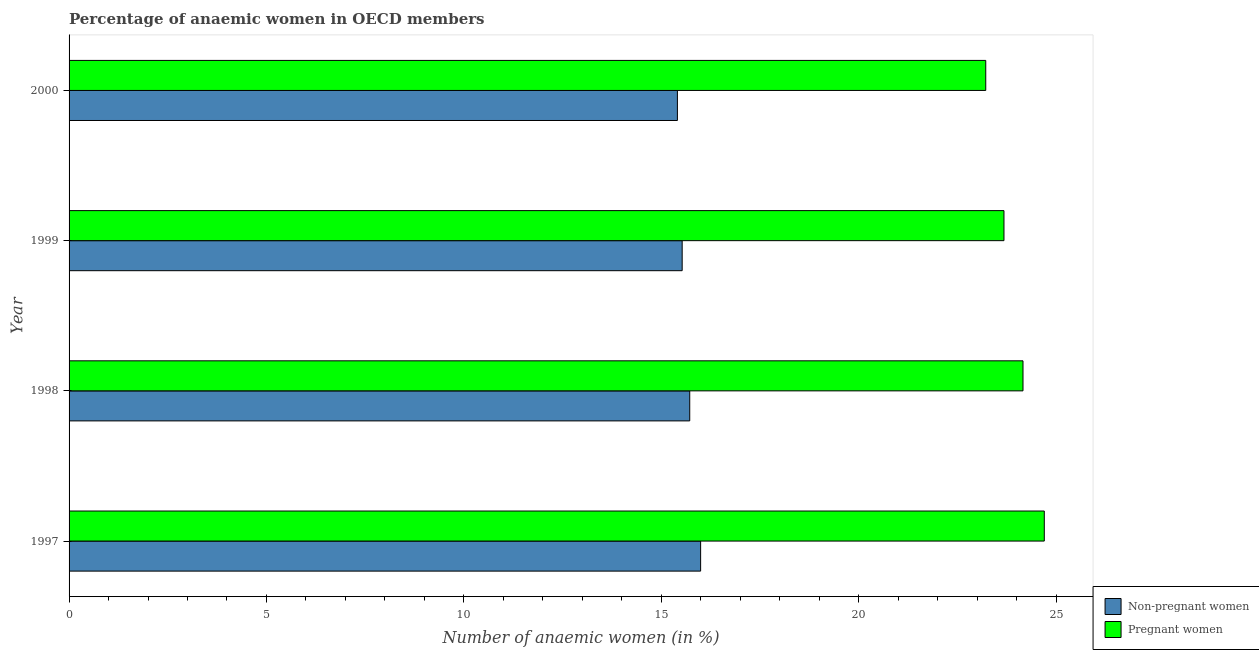Are the number of bars per tick equal to the number of legend labels?
Provide a short and direct response. Yes. How many bars are there on the 3rd tick from the top?
Offer a very short reply. 2. How many bars are there on the 2nd tick from the bottom?
Ensure brevity in your answer.  2. In how many cases, is the number of bars for a given year not equal to the number of legend labels?
Keep it short and to the point. 0. What is the percentage of pregnant anaemic women in 1997?
Provide a short and direct response. 24.7. Across all years, what is the maximum percentage of pregnant anaemic women?
Give a very brief answer. 24.7. Across all years, what is the minimum percentage of pregnant anaemic women?
Ensure brevity in your answer.  23.22. In which year was the percentage of non-pregnant anaemic women minimum?
Your response must be concise. 2000. What is the total percentage of pregnant anaemic women in the graph?
Your answer should be very brief. 95.77. What is the difference between the percentage of pregnant anaemic women in 1998 and that in 1999?
Give a very brief answer. 0.48. What is the difference between the percentage of pregnant anaemic women in 1998 and the percentage of non-pregnant anaemic women in 2000?
Provide a short and direct response. 8.75. What is the average percentage of non-pregnant anaemic women per year?
Provide a short and direct response. 15.66. In the year 1997, what is the difference between the percentage of pregnant anaemic women and percentage of non-pregnant anaemic women?
Provide a short and direct response. 8.71. In how many years, is the percentage of pregnant anaemic women greater than 15 %?
Your answer should be compact. 4. What is the ratio of the percentage of non-pregnant anaemic women in 1998 to that in 2000?
Make the answer very short. 1.02. What is the difference between the highest and the second highest percentage of pregnant anaemic women?
Keep it short and to the point. 0.54. What is the difference between the highest and the lowest percentage of pregnant anaemic women?
Your answer should be very brief. 1.48. In how many years, is the percentage of pregnant anaemic women greater than the average percentage of pregnant anaemic women taken over all years?
Provide a succinct answer. 2. What does the 2nd bar from the top in 2000 represents?
Your answer should be compact. Non-pregnant women. What does the 1st bar from the bottom in 1998 represents?
Give a very brief answer. Non-pregnant women. How many bars are there?
Ensure brevity in your answer.  8. Are all the bars in the graph horizontal?
Provide a short and direct response. Yes. What is the difference between two consecutive major ticks on the X-axis?
Your answer should be very brief. 5. Does the graph contain grids?
Keep it short and to the point. No. How are the legend labels stacked?
Your response must be concise. Vertical. What is the title of the graph?
Keep it short and to the point. Percentage of anaemic women in OECD members. What is the label or title of the X-axis?
Give a very brief answer. Number of anaemic women (in %). What is the label or title of the Y-axis?
Your response must be concise. Year. What is the Number of anaemic women (in %) in Non-pregnant women in 1997?
Provide a succinct answer. 16. What is the Number of anaemic women (in %) of Pregnant women in 1997?
Your answer should be compact. 24.7. What is the Number of anaemic women (in %) of Non-pregnant women in 1998?
Offer a very short reply. 15.72. What is the Number of anaemic women (in %) of Pregnant women in 1998?
Your answer should be very brief. 24.16. What is the Number of anaemic women (in %) of Non-pregnant women in 1999?
Provide a succinct answer. 15.53. What is the Number of anaemic women (in %) in Pregnant women in 1999?
Your response must be concise. 23.68. What is the Number of anaemic women (in %) of Non-pregnant women in 2000?
Keep it short and to the point. 15.41. What is the Number of anaemic women (in %) of Pregnant women in 2000?
Your response must be concise. 23.22. Across all years, what is the maximum Number of anaemic women (in %) of Non-pregnant women?
Offer a terse response. 16. Across all years, what is the maximum Number of anaemic women (in %) in Pregnant women?
Provide a short and direct response. 24.7. Across all years, what is the minimum Number of anaemic women (in %) of Non-pregnant women?
Provide a short and direct response. 15.41. Across all years, what is the minimum Number of anaemic women (in %) in Pregnant women?
Give a very brief answer. 23.22. What is the total Number of anaemic women (in %) in Non-pregnant women in the graph?
Provide a succinct answer. 62.66. What is the total Number of anaemic women (in %) of Pregnant women in the graph?
Make the answer very short. 95.77. What is the difference between the Number of anaemic women (in %) in Non-pregnant women in 1997 and that in 1998?
Your response must be concise. 0.28. What is the difference between the Number of anaemic women (in %) of Pregnant women in 1997 and that in 1998?
Your response must be concise. 0.54. What is the difference between the Number of anaemic women (in %) in Non-pregnant women in 1997 and that in 1999?
Your answer should be compact. 0.47. What is the difference between the Number of anaemic women (in %) of Pregnant women in 1997 and that in 1999?
Ensure brevity in your answer.  1.02. What is the difference between the Number of anaemic women (in %) in Non-pregnant women in 1997 and that in 2000?
Offer a terse response. 0.59. What is the difference between the Number of anaemic women (in %) of Pregnant women in 1997 and that in 2000?
Offer a very short reply. 1.48. What is the difference between the Number of anaemic women (in %) of Non-pregnant women in 1998 and that in 1999?
Your answer should be very brief. 0.19. What is the difference between the Number of anaemic women (in %) of Pregnant women in 1998 and that in 1999?
Provide a short and direct response. 0.48. What is the difference between the Number of anaemic women (in %) in Non-pregnant women in 1998 and that in 2000?
Provide a succinct answer. 0.31. What is the difference between the Number of anaemic women (in %) in Pregnant women in 1998 and that in 2000?
Give a very brief answer. 0.94. What is the difference between the Number of anaemic women (in %) of Non-pregnant women in 1999 and that in 2000?
Make the answer very short. 0.12. What is the difference between the Number of anaemic women (in %) in Pregnant women in 1999 and that in 2000?
Give a very brief answer. 0.46. What is the difference between the Number of anaemic women (in %) in Non-pregnant women in 1997 and the Number of anaemic women (in %) in Pregnant women in 1998?
Give a very brief answer. -8.17. What is the difference between the Number of anaemic women (in %) of Non-pregnant women in 1997 and the Number of anaemic women (in %) of Pregnant women in 1999?
Offer a terse response. -7.68. What is the difference between the Number of anaemic women (in %) in Non-pregnant women in 1997 and the Number of anaemic women (in %) in Pregnant women in 2000?
Your response must be concise. -7.22. What is the difference between the Number of anaemic women (in %) of Non-pregnant women in 1998 and the Number of anaemic women (in %) of Pregnant women in 1999?
Your response must be concise. -7.96. What is the difference between the Number of anaemic women (in %) of Non-pregnant women in 1998 and the Number of anaemic women (in %) of Pregnant women in 2000?
Provide a succinct answer. -7.5. What is the difference between the Number of anaemic women (in %) in Non-pregnant women in 1999 and the Number of anaemic women (in %) in Pregnant women in 2000?
Your answer should be very brief. -7.69. What is the average Number of anaemic women (in %) in Non-pregnant women per year?
Offer a very short reply. 15.66. What is the average Number of anaemic women (in %) of Pregnant women per year?
Your response must be concise. 23.94. In the year 1997, what is the difference between the Number of anaemic women (in %) in Non-pregnant women and Number of anaemic women (in %) in Pregnant women?
Ensure brevity in your answer.  -8.71. In the year 1998, what is the difference between the Number of anaemic women (in %) of Non-pregnant women and Number of anaemic women (in %) of Pregnant women?
Offer a terse response. -8.44. In the year 1999, what is the difference between the Number of anaemic women (in %) of Non-pregnant women and Number of anaemic women (in %) of Pregnant women?
Provide a succinct answer. -8.15. In the year 2000, what is the difference between the Number of anaemic women (in %) of Non-pregnant women and Number of anaemic women (in %) of Pregnant women?
Keep it short and to the point. -7.81. What is the ratio of the Number of anaemic women (in %) of Non-pregnant women in 1997 to that in 1998?
Keep it short and to the point. 1.02. What is the ratio of the Number of anaemic women (in %) in Pregnant women in 1997 to that in 1998?
Keep it short and to the point. 1.02. What is the ratio of the Number of anaemic women (in %) of Non-pregnant women in 1997 to that in 1999?
Ensure brevity in your answer.  1.03. What is the ratio of the Number of anaemic women (in %) in Pregnant women in 1997 to that in 1999?
Your answer should be very brief. 1.04. What is the ratio of the Number of anaemic women (in %) of Non-pregnant women in 1997 to that in 2000?
Provide a succinct answer. 1.04. What is the ratio of the Number of anaemic women (in %) in Pregnant women in 1997 to that in 2000?
Make the answer very short. 1.06. What is the ratio of the Number of anaemic women (in %) of Non-pregnant women in 1998 to that in 1999?
Keep it short and to the point. 1.01. What is the ratio of the Number of anaemic women (in %) in Pregnant women in 1998 to that in 1999?
Make the answer very short. 1.02. What is the ratio of the Number of anaemic women (in %) of Non-pregnant women in 1998 to that in 2000?
Make the answer very short. 1.02. What is the ratio of the Number of anaemic women (in %) of Pregnant women in 1998 to that in 2000?
Your response must be concise. 1.04. What is the ratio of the Number of anaemic women (in %) in Non-pregnant women in 1999 to that in 2000?
Ensure brevity in your answer.  1.01. What is the ratio of the Number of anaemic women (in %) of Pregnant women in 1999 to that in 2000?
Your response must be concise. 1.02. What is the difference between the highest and the second highest Number of anaemic women (in %) of Non-pregnant women?
Ensure brevity in your answer.  0.28. What is the difference between the highest and the second highest Number of anaemic women (in %) of Pregnant women?
Keep it short and to the point. 0.54. What is the difference between the highest and the lowest Number of anaemic women (in %) of Non-pregnant women?
Provide a short and direct response. 0.59. What is the difference between the highest and the lowest Number of anaemic women (in %) in Pregnant women?
Your response must be concise. 1.48. 